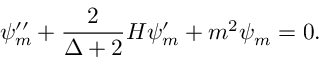Convert formula to latex. <formula><loc_0><loc_0><loc_500><loc_500>\psi _ { m } ^ { \prime \prime } + \frac { 2 } { \Delta + 2 } H \psi _ { m } ^ { \prime } + m ^ { 2 } \psi _ { m } = 0 .</formula> 